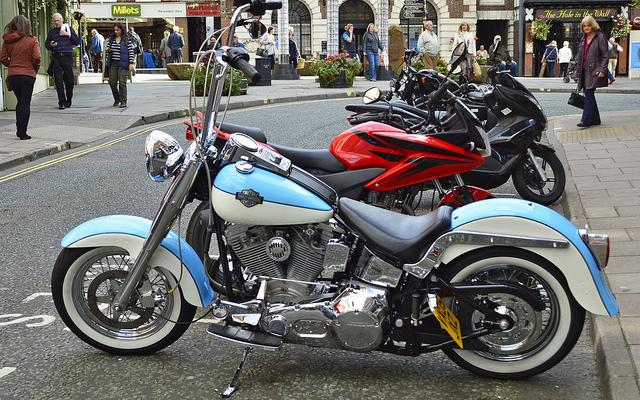What color is the motorcycle seat?
Concise answer only. Black. Which one is blue and white?
Quick response, please. Front one. How many motorcycles are there?
Answer briefly. 4. What color is the motorcycle in front?
Short answer required. Blue. What name is on the green sign in the background?
Short answer required. Millets. 